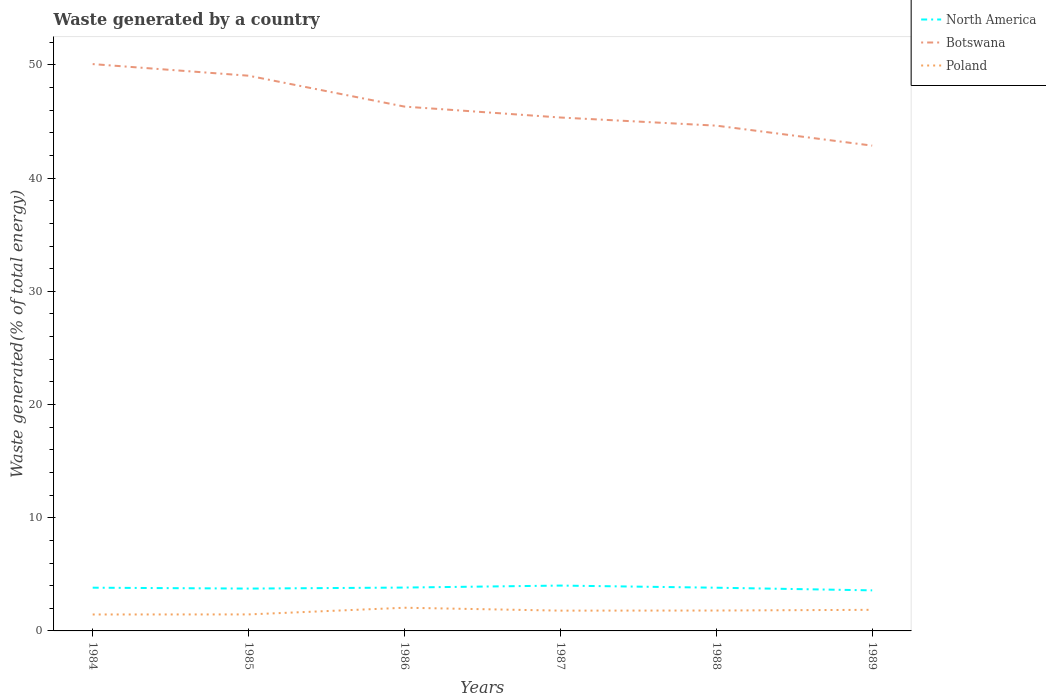How many different coloured lines are there?
Keep it short and to the point. 3. Does the line corresponding to Poland intersect with the line corresponding to Botswana?
Your answer should be very brief. No. Is the number of lines equal to the number of legend labels?
Provide a succinct answer. Yes. Across all years, what is the maximum total waste generated in Botswana?
Provide a succinct answer. 42.87. In which year was the total waste generated in Botswana maximum?
Make the answer very short. 1989. What is the total total waste generated in Poland in the graph?
Keep it short and to the point. -0.01. What is the difference between the highest and the second highest total waste generated in North America?
Offer a very short reply. 0.42. What is the difference between the highest and the lowest total waste generated in Poland?
Provide a succinct answer. 4. How many lines are there?
Offer a terse response. 3. How many years are there in the graph?
Offer a terse response. 6. Are the values on the major ticks of Y-axis written in scientific E-notation?
Offer a terse response. No. Does the graph contain any zero values?
Ensure brevity in your answer.  No. Where does the legend appear in the graph?
Your answer should be compact. Top right. How many legend labels are there?
Provide a succinct answer. 3. How are the legend labels stacked?
Make the answer very short. Vertical. What is the title of the graph?
Make the answer very short. Waste generated by a country. What is the label or title of the Y-axis?
Your answer should be compact. Waste generated(% of total energy). What is the Waste generated(% of total energy) in North America in 1984?
Your answer should be compact. 3.82. What is the Waste generated(% of total energy) in Botswana in 1984?
Make the answer very short. 50.08. What is the Waste generated(% of total energy) in Poland in 1984?
Your response must be concise. 1.45. What is the Waste generated(% of total energy) of North America in 1985?
Ensure brevity in your answer.  3.74. What is the Waste generated(% of total energy) of Botswana in 1985?
Your answer should be compact. 49.05. What is the Waste generated(% of total energy) in Poland in 1985?
Keep it short and to the point. 1.46. What is the Waste generated(% of total energy) of North America in 1986?
Provide a succinct answer. 3.83. What is the Waste generated(% of total energy) of Botswana in 1986?
Provide a short and direct response. 46.32. What is the Waste generated(% of total energy) of Poland in 1986?
Make the answer very short. 2.05. What is the Waste generated(% of total energy) of North America in 1987?
Provide a short and direct response. 4.01. What is the Waste generated(% of total energy) of Botswana in 1987?
Ensure brevity in your answer.  45.36. What is the Waste generated(% of total energy) of Poland in 1987?
Ensure brevity in your answer.  1.79. What is the Waste generated(% of total energy) of North America in 1988?
Make the answer very short. 3.82. What is the Waste generated(% of total energy) in Botswana in 1988?
Keep it short and to the point. 44.64. What is the Waste generated(% of total energy) in Poland in 1988?
Your response must be concise. 1.8. What is the Waste generated(% of total energy) of North America in 1989?
Your answer should be very brief. 3.58. What is the Waste generated(% of total energy) in Botswana in 1989?
Your answer should be very brief. 42.87. What is the Waste generated(% of total energy) in Poland in 1989?
Give a very brief answer. 1.86. Across all years, what is the maximum Waste generated(% of total energy) in North America?
Make the answer very short. 4.01. Across all years, what is the maximum Waste generated(% of total energy) in Botswana?
Keep it short and to the point. 50.08. Across all years, what is the maximum Waste generated(% of total energy) in Poland?
Your answer should be compact. 2.05. Across all years, what is the minimum Waste generated(% of total energy) of North America?
Provide a short and direct response. 3.58. Across all years, what is the minimum Waste generated(% of total energy) of Botswana?
Offer a terse response. 42.87. Across all years, what is the minimum Waste generated(% of total energy) of Poland?
Make the answer very short. 1.45. What is the total Waste generated(% of total energy) of North America in the graph?
Make the answer very short. 22.8. What is the total Waste generated(% of total energy) in Botswana in the graph?
Offer a very short reply. 278.31. What is the total Waste generated(% of total energy) in Poland in the graph?
Your answer should be compact. 10.42. What is the difference between the Waste generated(% of total energy) in North America in 1984 and that in 1985?
Provide a succinct answer. 0.08. What is the difference between the Waste generated(% of total energy) in Botswana in 1984 and that in 1985?
Offer a terse response. 1.03. What is the difference between the Waste generated(% of total energy) in Poland in 1984 and that in 1985?
Ensure brevity in your answer.  -0.01. What is the difference between the Waste generated(% of total energy) in North America in 1984 and that in 1986?
Ensure brevity in your answer.  -0.01. What is the difference between the Waste generated(% of total energy) in Botswana in 1984 and that in 1986?
Your answer should be very brief. 3.75. What is the difference between the Waste generated(% of total energy) in Poland in 1984 and that in 1986?
Offer a very short reply. -0.6. What is the difference between the Waste generated(% of total energy) of North America in 1984 and that in 1987?
Offer a terse response. -0.19. What is the difference between the Waste generated(% of total energy) of Botswana in 1984 and that in 1987?
Offer a terse response. 4.72. What is the difference between the Waste generated(% of total energy) of Poland in 1984 and that in 1987?
Give a very brief answer. -0.34. What is the difference between the Waste generated(% of total energy) in North America in 1984 and that in 1988?
Ensure brevity in your answer.  0. What is the difference between the Waste generated(% of total energy) in Botswana in 1984 and that in 1988?
Your response must be concise. 5.44. What is the difference between the Waste generated(% of total energy) of Poland in 1984 and that in 1988?
Give a very brief answer. -0.35. What is the difference between the Waste generated(% of total energy) in North America in 1984 and that in 1989?
Your answer should be very brief. 0.23. What is the difference between the Waste generated(% of total energy) in Botswana in 1984 and that in 1989?
Your answer should be very brief. 7.2. What is the difference between the Waste generated(% of total energy) of Poland in 1984 and that in 1989?
Your response must be concise. -0.41. What is the difference between the Waste generated(% of total energy) of North America in 1985 and that in 1986?
Keep it short and to the point. -0.09. What is the difference between the Waste generated(% of total energy) of Botswana in 1985 and that in 1986?
Keep it short and to the point. 2.73. What is the difference between the Waste generated(% of total energy) of Poland in 1985 and that in 1986?
Your answer should be very brief. -0.59. What is the difference between the Waste generated(% of total energy) in North America in 1985 and that in 1987?
Offer a very short reply. -0.27. What is the difference between the Waste generated(% of total energy) in Botswana in 1985 and that in 1987?
Your response must be concise. 3.69. What is the difference between the Waste generated(% of total energy) in Poland in 1985 and that in 1987?
Your response must be concise. -0.33. What is the difference between the Waste generated(% of total energy) of North America in 1985 and that in 1988?
Provide a succinct answer. -0.08. What is the difference between the Waste generated(% of total energy) in Botswana in 1985 and that in 1988?
Make the answer very short. 4.41. What is the difference between the Waste generated(% of total energy) of Poland in 1985 and that in 1988?
Provide a succinct answer. -0.34. What is the difference between the Waste generated(% of total energy) of North America in 1985 and that in 1989?
Provide a short and direct response. 0.16. What is the difference between the Waste generated(% of total energy) in Botswana in 1985 and that in 1989?
Offer a very short reply. 6.18. What is the difference between the Waste generated(% of total energy) in Poland in 1985 and that in 1989?
Provide a short and direct response. -0.41. What is the difference between the Waste generated(% of total energy) in North America in 1986 and that in 1987?
Offer a terse response. -0.18. What is the difference between the Waste generated(% of total energy) in Botswana in 1986 and that in 1987?
Ensure brevity in your answer.  0.96. What is the difference between the Waste generated(% of total energy) in Poland in 1986 and that in 1987?
Make the answer very short. 0.26. What is the difference between the Waste generated(% of total energy) of North America in 1986 and that in 1988?
Offer a terse response. 0.01. What is the difference between the Waste generated(% of total energy) of Botswana in 1986 and that in 1988?
Your answer should be very brief. 1.68. What is the difference between the Waste generated(% of total energy) in Poland in 1986 and that in 1988?
Provide a short and direct response. 0.25. What is the difference between the Waste generated(% of total energy) in North America in 1986 and that in 1989?
Give a very brief answer. 0.25. What is the difference between the Waste generated(% of total energy) of Botswana in 1986 and that in 1989?
Offer a terse response. 3.45. What is the difference between the Waste generated(% of total energy) in Poland in 1986 and that in 1989?
Your answer should be compact. 0.18. What is the difference between the Waste generated(% of total energy) of North America in 1987 and that in 1988?
Your answer should be very brief. 0.19. What is the difference between the Waste generated(% of total energy) of Botswana in 1987 and that in 1988?
Offer a very short reply. 0.72. What is the difference between the Waste generated(% of total energy) of Poland in 1987 and that in 1988?
Provide a short and direct response. -0.01. What is the difference between the Waste generated(% of total energy) in North America in 1987 and that in 1989?
Keep it short and to the point. 0.42. What is the difference between the Waste generated(% of total energy) in Botswana in 1987 and that in 1989?
Your answer should be very brief. 2.48. What is the difference between the Waste generated(% of total energy) in Poland in 1987 and that in 1989?
Offer a terse response. -0.07. What is the difference between the Waste generated(% of total energy) of North America in 1988 and that in 1989?
Your answer should be very brief. 0.23. What is the difference between the Waste generated(% of total energy) of Botswana in 1988 and that in 1989?
Keep it short and to the point. 1.76. What is the difference between the Waste generated(% of total energy) of Poland in 1988 and that in 1989?
Provide a short and direct response. -0.06. What is the difference between the Waste generated(% of total energy) in North America in 1984 and the Waste generated(% of total energy) in Botswana in 1985?
Offer a very short reply. -45.23. What is the difference between the Waste generated(% of total energy) of North America in 1984 and the Waste generated(% of total energy) of Poland in 1985?
Give a very brief answer. 2.36. What is the difference between the Waste generated(% of total energy) in Botswana in 1984 and the Waste generated(% of total energy) in Poland in 1985?
Provide a succinct answer. 48.62. What is the difference between the Waste generated(% of total energy) of North America in 1984 and the Waste generated(% of total energy) of Botswana in 1986?
Offer a terse response. -42.5. What is the difference between the Waste generated(% of total energy) of North America in 1984 and the Waste generated(% of total energy) of Poland in 1986?
Provide a short and direct response. 1.77. What is the difference between the Waste generated(% of total energy) of Botswana in 1984 and the Waste generated(% of total energy) of Poland in 1986?
Keep it short and to the point. 48.03. What is the difference between the Waste generated(% of total energy) in North America in 1984 and the Waste generated(% of total energy) in Botswana in 1987?
Your response must be concise. -41.54. What is the difference between the Waste generated(% of total energy) in North America in 1984 and the Waste generated(% of total energy) in Poland in 1987?
Your answer should be compact. 2.03. What is the difference between the Waste generated(% of total energy) in Botswana in 1984 and the Waste generated(% of total energy) in Poland in 1987?
Offer a terse response. 48.28. What is the difference between the Waste generated(% of total energy) in North America in 1984 and the Waste generated(% of total energy) in Botswana in 1988?
Make the answer very short. -40.82. What is the difference between the Waste generated(% of total energy) of North America in 1984 and the Waste generated(% of total energy) of Poland in 1988?
Give a very brief answer. 2.02. What is the difference between the Waste generated(% of total energy) of Botswana in 1984 and the Waste generated(% of total energy) of Poland in 1988?
Your answer should be very brief. 48.27. What is the difference between the Waste generated(% of total energy) in North America in 1984 and the Waste generated(% of total energy) in Botswana in 1989?
Offer a very short reply. -39.05. What is the difference between the Waste generated(% of total energy) in North America in 1984 and the Waste generated(% of total energy) in Poland in 1989?
Your answer should be very brief. 1.95. What is the difference between the Waste generated(% of total energy) in Botswana in 1984 and the Waste generated(% of total energy) in Poland in 1989?
Your answer should be very brief. 48.21. What is the difference between the Waste generated(% of total energy) in North America in 1985 and the Waste generated(% of total energy) in Botswana in 1986?
Offer a terse response. -42.58. What is the difference between the Waste generated(% of total energy) of North America in 1985 and the Waste generated(% of total energy) of Poland in 1986?
Make the answer very short. 1.69. What is the difference between the Waste generated(% of total energy) of Botswana in 1985 and the Waste generated(% of total energy) of Poland in 1986?
Your response must be concise. 47. What is the difference between the Waste generated(% of total energy) of North America in 1985 and the Waste generated(% of total energy) of Botswana in 1987?
Provide a succinct answer. -41.62. What is the difference between the Waste generated(% of total energy) in North America in 1985 and the Waste generated(% of total energy) in Poland in 1987?
Keep it short and to the point. 1.95. What is the difference between the Waste generated(% of total energy) in Botswana in 1985 and the Waste generated(% of total energy) in Poland in 1987?
Your answer should be compact. 47.26. What is the difference between the Waste generated(% of total energy) of North America in 1985 and the Waste generated(% of total energy) of Botswana in 1988?
Keep it short and to the point. -40.9. What is the difference between the Waste generated(% of total energy) of North America in 1985 and the Waste generated(% of total energy) of Poland in 1988?
Your response must be concise. 1.94. What is the difference between the Waste generated(% of total energy) in Botswana in 1985 and the Waste generated(% of total energy) in Poland in 1988?
Your answer should be compact. 47.25. What is the difference between the Waste generated(% of total energy) of North America in 1985 and the Waste generated(% of total energy) of Botswana in 1989?
Provide a succinct answer. -39.13. What is the difference between the Waste generated(% of total energy) of North America in 1985 and the Waste generated(% of total energy) of Poland in 1989?
Make the answer very short. 1.88. What is the difference between the Waste generated(% of total energy) of Botswana in 1985 and the Waste generated(% of total energy) of Poland in 1989?
Your answer should be compact. 47.18. What is the difference between the Waste generated(% of total energy) of North America in 1986 and the Waste generated(% of total energy) of Botswana in 1987?
Offer a very short reply. -41.53. What is the difference between the Waste generated(% of total energy) of North America in 1986 and the Waste generated(% of total energy) of Poland in 1987?
Provide a short and direct response. 2.04. What is the difference between the Waste generated(% of total energy) in Botswana in 1986 and the Waste generated(% of total energy) in Poland in 1987?
Give a very brief answer. 44.53. What is the difference between the Waste generated(% of total energy) of North America in 1986 and the Waste generated(% of total energy) of Botswana in 1988?
Offer a terse response. -40.81. What is the difference between the Waste generated(% of total energy) in North America in 1986 and the Waste generated(% of total energy) in Poland in 1988?
Your response must be concise. 2.03. What is the difference between the Waste generated(% of total energy) of Botswana in 1986 and the Waste generated(% of total energy) of Poland in 1988?
Your response must be concise. 44.52. What is the difference between the Waste generated(% of total energy) in North America in 1986 and the Waste generated(% of total energy) in Botswana in 1989?
Your response must be concise. -39.04. What is the difference between the Waste generated(% of total energy) of North America in 1986 and the Waste generated(% of total energy) of Poland in 1989?
Provide a succinct answer. 1.97. What is the difference between the Waste generated(% of total energy) in Botswana in 1986 and the Waste generated(% of total energy) in Poland in 1989?
Provide a succinct answer. 44.46. What is the difference between the Waste generated(% of total energy) in North America in 1987 and the Waste generated(% of total energy) in Botswana in 1988?
Your answer should be compact. -40.63. What is the difference between the Waste generated(% of total energy) of North America in 1987 and the Waste generated(% of total energy) of Poland in 1988?
Keep it short and to the point. 2.2. What is the difference between the Waste generated(% of total energy) of Botswana in 1987 and the Waste generated(% of total energy) of Poland in 1988?
Make the answer very short. 43.55. What is the difference between the Waste generated(% of total energy) of North America in 1987 and the Waste generated(% of total energy) of Botswana in 1989?
Keep it short and to the point. -38.87. What is the difference between the Waste generated(% of total energy) in North America in 1987 and the Waste generated(% of total energy) in Poland in 1989?
Give a very brief answer. 2.14. What is the difference between the Waste generated(% of total energy) of Botswana in 1987 and the Waste generated(% of total energy) of Poland in 1989?
Ensure brevity in your answer.  43.49. What is the difference between the Waste generated(% of total energy) of North America in 1988 and the Waste generated(% of total energy) of Botswana in 1989?
Offer a terse response. -39.06. What is the difference between the Waste generated(% of total energy) of North America in 1988 and the Waste generated(% of total energy) of Poland in 1989?
Your response must be concise. 1.95. What is the difference between the Waste generated(% of total energy) of Botswana in 1988 and the Waste generated(% of total energy) of Poland in 1989?
Your answer should be very brief. 42.77. What is the average Waste generated(% of total energy) of North America per year?
Provide a succinct answer. 3.8. What is the average Waste generated(% of total energy) of Botswana per year?
Provide a short and direct response. 46.39. What is the average Waste generated(% of total energy) in Poland per year?
Your response must be concise. 1.74. In the year 1984, what is the difference between the Waste generated(% of total energy) of North America and Waste generated(% of total energy) of Botswana?
Your response must be concise. -46.26. In the year 1984, what is the difference between the Waste generated(% of total energy) of North America and Waste generated(% of total energy) of Poland?
Your answer should be very brief. 2.37. In the year 1984, what is the difference between the Waste generated(% of total energy) of Botswana and Waste generated(% of total energy) of Poland?
Give a very brief answer. 48.62. In the year 1985, what is the difference between the Waste generated(% of total energy) in North America and Waste generated(% of total energy) in Botswana?
Provide a succinct answer. -45.31. In the year 1985, what is the difference between the Waste generated(% of total energy) in North America and Waste generated(% of total energy) in Poland?
Give a very brief answer. 2.28. In the year 1985, what is the difference between the Waste generated(% of total energy) in Botswana and Waste generated(% of total energy) in Poland?
Provide a short and direct response. 47.59. In the year 1986, what is the difference between the Waste generated(% of total energy) of North America and Waste generated(% of total energy) of Botswana?
Make the answer very short. -42.49. In the year 1986, what is the difference between the Waste generated(% of total energy) of North America and Waste generated(% of total energy) of Poland?
Provide a succinct answer. 1.78. In the year 1986, what is the difference between the Waste generated(% of total energy) in Botswana and Waste generated(% of total energy) in Poland?
Provide a succinct answer. 44.27. In the year 1987, what is the difference between the Waste generated(% of total energy) of North America and Waste generated(% of total energy) of Botswana?
Keep it short and to the point. -41.35. In the year 1987, what is the difference between the Waste generated(% of total energy) in North America and Waste generated(% of total energy) in Poland?
Your answer should be very brief. 2.21. In the year 1987, what is the difference between the Waste generated(% of total energy) of Botswana and Waste generated(% of total energy) of Poland?
Provide a succinct answer. 43.56. In the year 1988, what is the difference between the Waste generated(% of total energy) of North America and Waste generated(% of total energy) of Botswana?
Provide a succinct answer. -40.82. In the year 1988, what is the difference between the Waste generated(% of total energy) of North America and Waste generated(% of total energy) of Poland?
Keep it short and to the point. 2.02. In the year 1988, what is the difference between the Waste generated(% of total energy) of Botswana and Waste generated(% of total energy) of Poland?
Make the answer very short. 42.84. In the year 1989, what is the difference between the Waste generated(% of total energy) of North America and Waste generated(% of total energy) of Botswana?
Provide a succinct answer. -39.29. In the year 1989, what is the difference between the Waste generated(% of total energy) in North America and Waste generated(% of total energy) in Poland?
Ensure brevity in your answer.  1.72. In the year 1989, what is the difference between the Waste generated(% of total energy) of Botswana and Waste generated(% of total energy) of Poland?
Your response must be concise. 41.01. What is the ratio of the Waste generated(% of total energy) of North America in 1984 to that in 1985?
Offer a very short reply. 1.02. What is the ratio of the Waste generated(% of total energy) of Botswana in 1984 to that in 1985?
Give a very brief answer. 1.02. What is the ratio of the Waste generated(% of total energy) in North America in 1984 to that in 1986?
Make the answer very short. 1. What is the ratio of the Waste generated(% of total energy) in Botswana in 1984 to that in 1986?
Make the answer very short. 1.08. What is the ratio of the Waste generated(% of total energy) of Poland in 1984 to that in 1986?
Your answer should be compact. 0.71. What is the ratio of the Waste generated(% of total energy) of North America in 1984 to that in 1987?
Provide a succinct answer. 0.95. What is the ratio of the Waste generated(% of total energy) in Botswana in 1984 to that in 1987?
Your answer should be very brief. 1.1. What is the ratio of the Waste generated(% of total energy) of Poland in 1984 to that in 1987?
Ensure brevity in your answer.  0.81. What is the ratio of the Waste generated(% of total energy) of North America in 1984 to that in 1988?
Provide a succinct answer. 1. What is the ratio of the Waste generated(% of total energy) in Botswana in 1984 to that in 1988?
Keep it short and to the point. 1.12. What is the ratio of the Waste generated(% of total energy) in Poland in 1984 to that in 1988?
Provide a succinct answer. 0.81. What is the ratio of the Waste generated(% of total energy) in North America in 1984 to that in 1989?
Your response must be concise. 1.07. What is the ratio of the Waste generated(% of total energy) of Botswana in 1984 to that in 1989?
Your answer should be very brief. 1.17. What is the ratio of the Waste generated(% of total energy) in Poland in 1984 to that in 1989?
Provide a short and direct response. 0.78. What is the ratio of the Waste generated(% of total energy) in North America in 1985 to that in 1986?
Offer a very short reply. 0.98. What is the ratio of the Waste generated(% of total energy) of Botswana in 1985 to that in 1986?
Ensure brevity in your answer.  1.06. What is the ratio of the Waste generated(% of total energy) of Poland in 1985 to that in 1986?
Give a very brief answer. 0.71. What is the ratio of the Waste generated(% of total energy) in North America in 1985 to that in 1987?
Keep it short and to the point. 0.93. What is the ratio of the Waste generated(% of total energy) in Botswana in 1985 to that in 1987?
Your response must be concise. 1.08. What is the ratio of the Waste generated(% of total energy) of Poland in 1985 to that in 1987?
Keep it short and to the point. 0.81. What is the ratio of the Waste generated(% of total energy) in North America in 1985 to that in 1988?
Offer a terse response. 0.98. What is the ratio of the Waste generated(% of total energy) in Botswana in 1985 to that in 1988?
Your answer should be compact. 1.1. What is the ratio of the Waste generated(% of total energy) in Poland in 1985 to that in 1988?
Provide a short and direct response. 0.81. What is the ratio of the Waste generated(% of total energy) of North America in 1985 to that in 1989?
Provide a short and direct response. 1.04. What is the ratio of the Waste generated(% of total energy) in Botswana in 1985 to that in 1989?
Keep it short and to the point. 1.14. What is the ratio of the Waste generated(% of total energy) in Poland in 1985 to that in 1989?
Make the answer very short. 0.78. What is the ratio of the Waste generated(% of total energy) of North America in 1986 to that in 1987?
Ensure brevity in your answer.  0.96. What is the ratio of the Waste generated(% of total energy) in Botswana in 1986 to that in 1987?
Provide a short and direct response. 1.02. What is the ratio of the Waste generated(% of total energy) in Poland in 1986 to that in 1987?
Your answer should be compact. 1.14. What is the ratio of the Waste generated(% of total energy) of North America in 1986 to that in 1988?
Provide a short and direct response. 1. What is the ratio of the Waste generated(% of total energy) of Botswana in 1986 to that in 1988?
Your answer should be compact. 1.04. What is the ratio of the Waste generated(% of total energy) of Poland in 1986 to that in 1988?
Offer a very short reply. 1.14. What is the ratio of the Waste generated(% of total energy) in North America in 1986 to that in 1989?
Your answer should be compact. 1.07. What is the ratio of the Waste generated(% of total energy) in Botswana in 1986 to that in 1989?
Your response must be concise. 1.08. What is the ratio of the Waste generated(% of total energy) in Poland in 1986 to that in 1989?
Provide a short and direct response. 1.1. What is the ratio of the Waste generated(% of total energy) of North America in 1987 to that in 1988?
Offer a very short reply. 1.05. What is the ratio of the Waste generated(% of total energy) of Botswana in 1987 to that in 1988?
Provide a short and direct response. 1.02. What is the ratio of the Waste generated(% of total energy) in North America in 1987 to that in 1989?
Your answer should be compact. 1.12. What is the ratio of the Waste generated(% of total energy) of Botswana in 1987 to that in 1989?
Offer a very short reply. 1.06. What is the ratio of the Waste generated(% of total energy) of Poland in 1987 to that in 1989?
Give a very brief answer. 0.96. What is the ratio of the Waste generated(% of total energy) of North America in 1988 to that in 1989?
Provide a short and direct response. 1.07. What is the ratio of the Waste generated(% of total energy) in Botswana in 1988 to that in 1989?
Offer a terse response. 1.04. What is the ratio of the Waste generated(% of total energy) of Poland in 1988 to that in 1989?
Offer a terse response. 0.97. What is the difference between the highest and the second highest Waste generated(% of total energy) in North America?
Ensure brevity in your answer.  0.18. What is the difference between the highest and the second highest Waste generated(% of total energy) in Botswana?
Make the answer very short. 1.03. What is the difference between the highest and the second highest Waste generated(% of total energy) of Poland?
Offer a terse response. 0.18. What is the difference between the highest and the lowest Waste generated(% of total energy) in North America?
Give a very brief answer. 0.42. What is the difference between the highest and the lowest Waste generated(% of total energy) of Botswana?
Your answer should be compact. 7.2. What is the difference between the highest and the lowest Waste generated(% of total energy) in Poland?
Your answer should be compact. 0.6. 